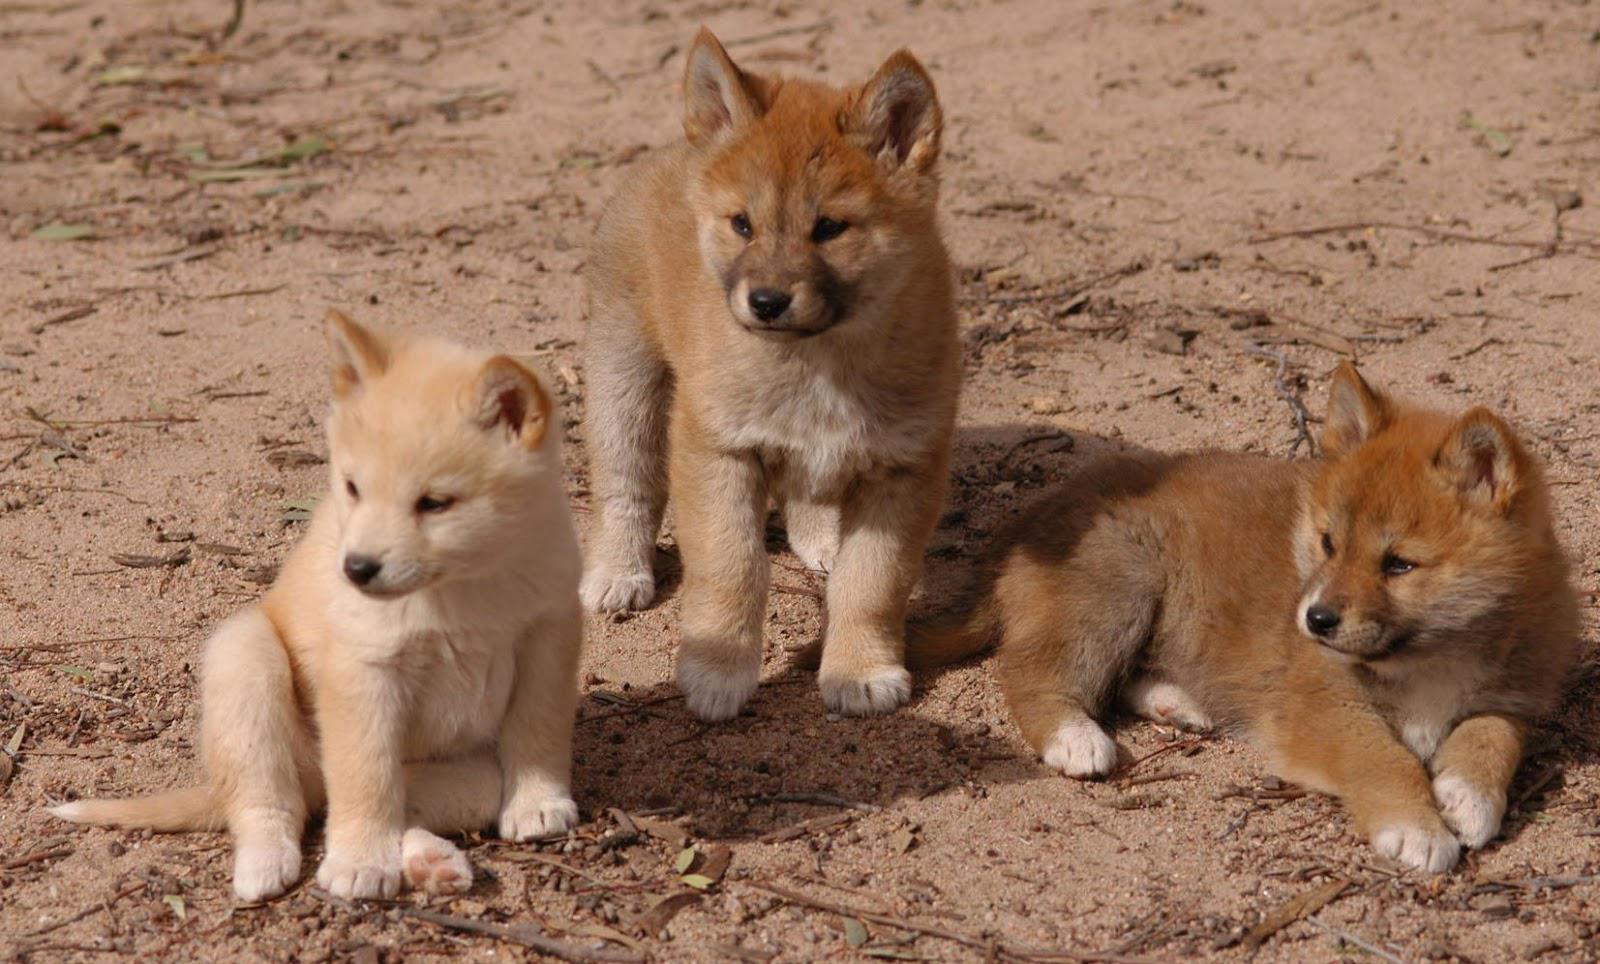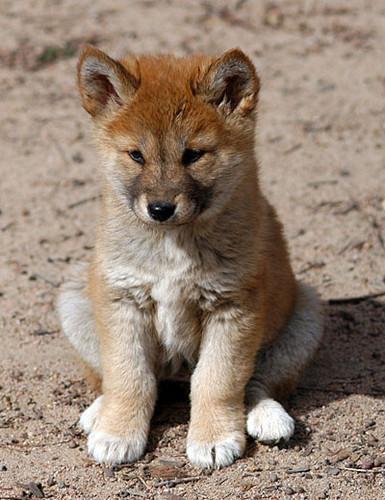The first image is the image on the left, the second image is the image on the right. Considering the images on both sides, is "The right image features a single dog posed outdoors facing forwards." valid? Answer yes or no. Yes. 